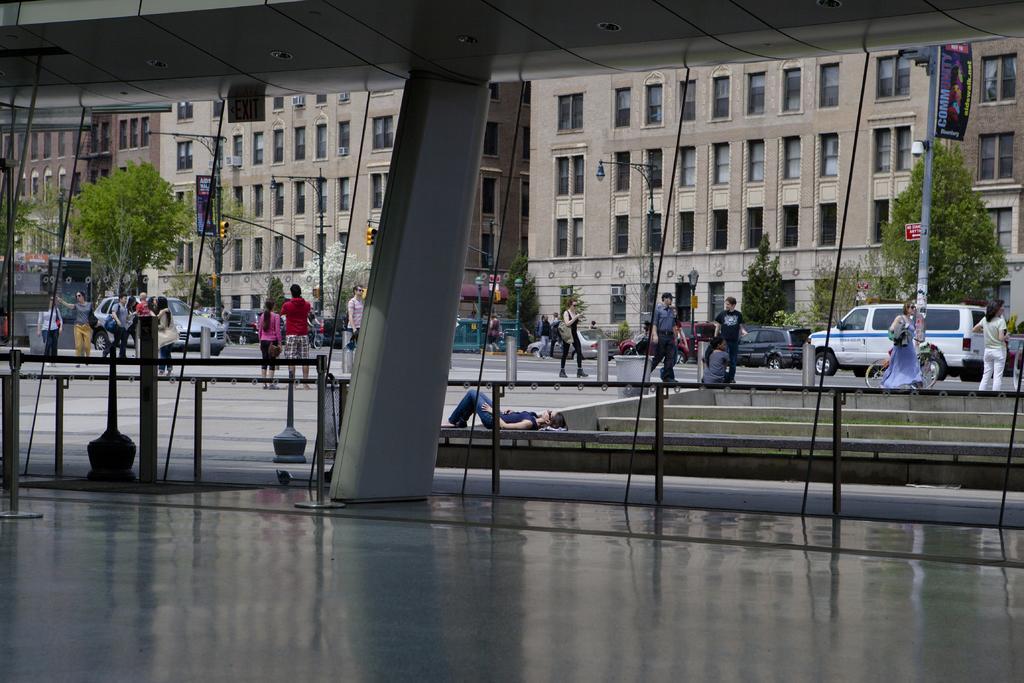Please provide a concise description of this image. Bottom of the image there is a fencing. Behind the fencing few people are standing and walking and few people are lying. Behind them there are some vehicles on the road and there are some poles and trees. Behind the trees there are some buildings. Top of the image there is roof. 